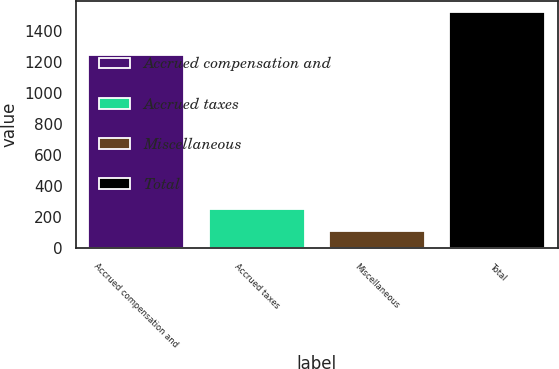Convert chart. <chart><loc_0><loc_0><loc_500><loc_500><bar_chart><fcel>Accrued compensation and<fcel>Accrued taxes<fcel>Miscellaneous<fcel>Total<nl><fcel>1249.7<fcel>252.3<fcel>111.1<fcel>1523.1<nl></chart> 